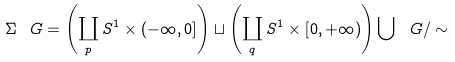<formula> <loc_0><loc_0><loc_500><loc_500>\Sigma _ { \ } G = \left ( \coprod _ { p } S ^ { 1 } \times ( - \infty , 0 ] \right ) \sqcup \left ( \coprod _ { q } S ^ { 1 } \times [ 0 , + \infty ) \right ) \bigcup \ G / \sim</formula> 